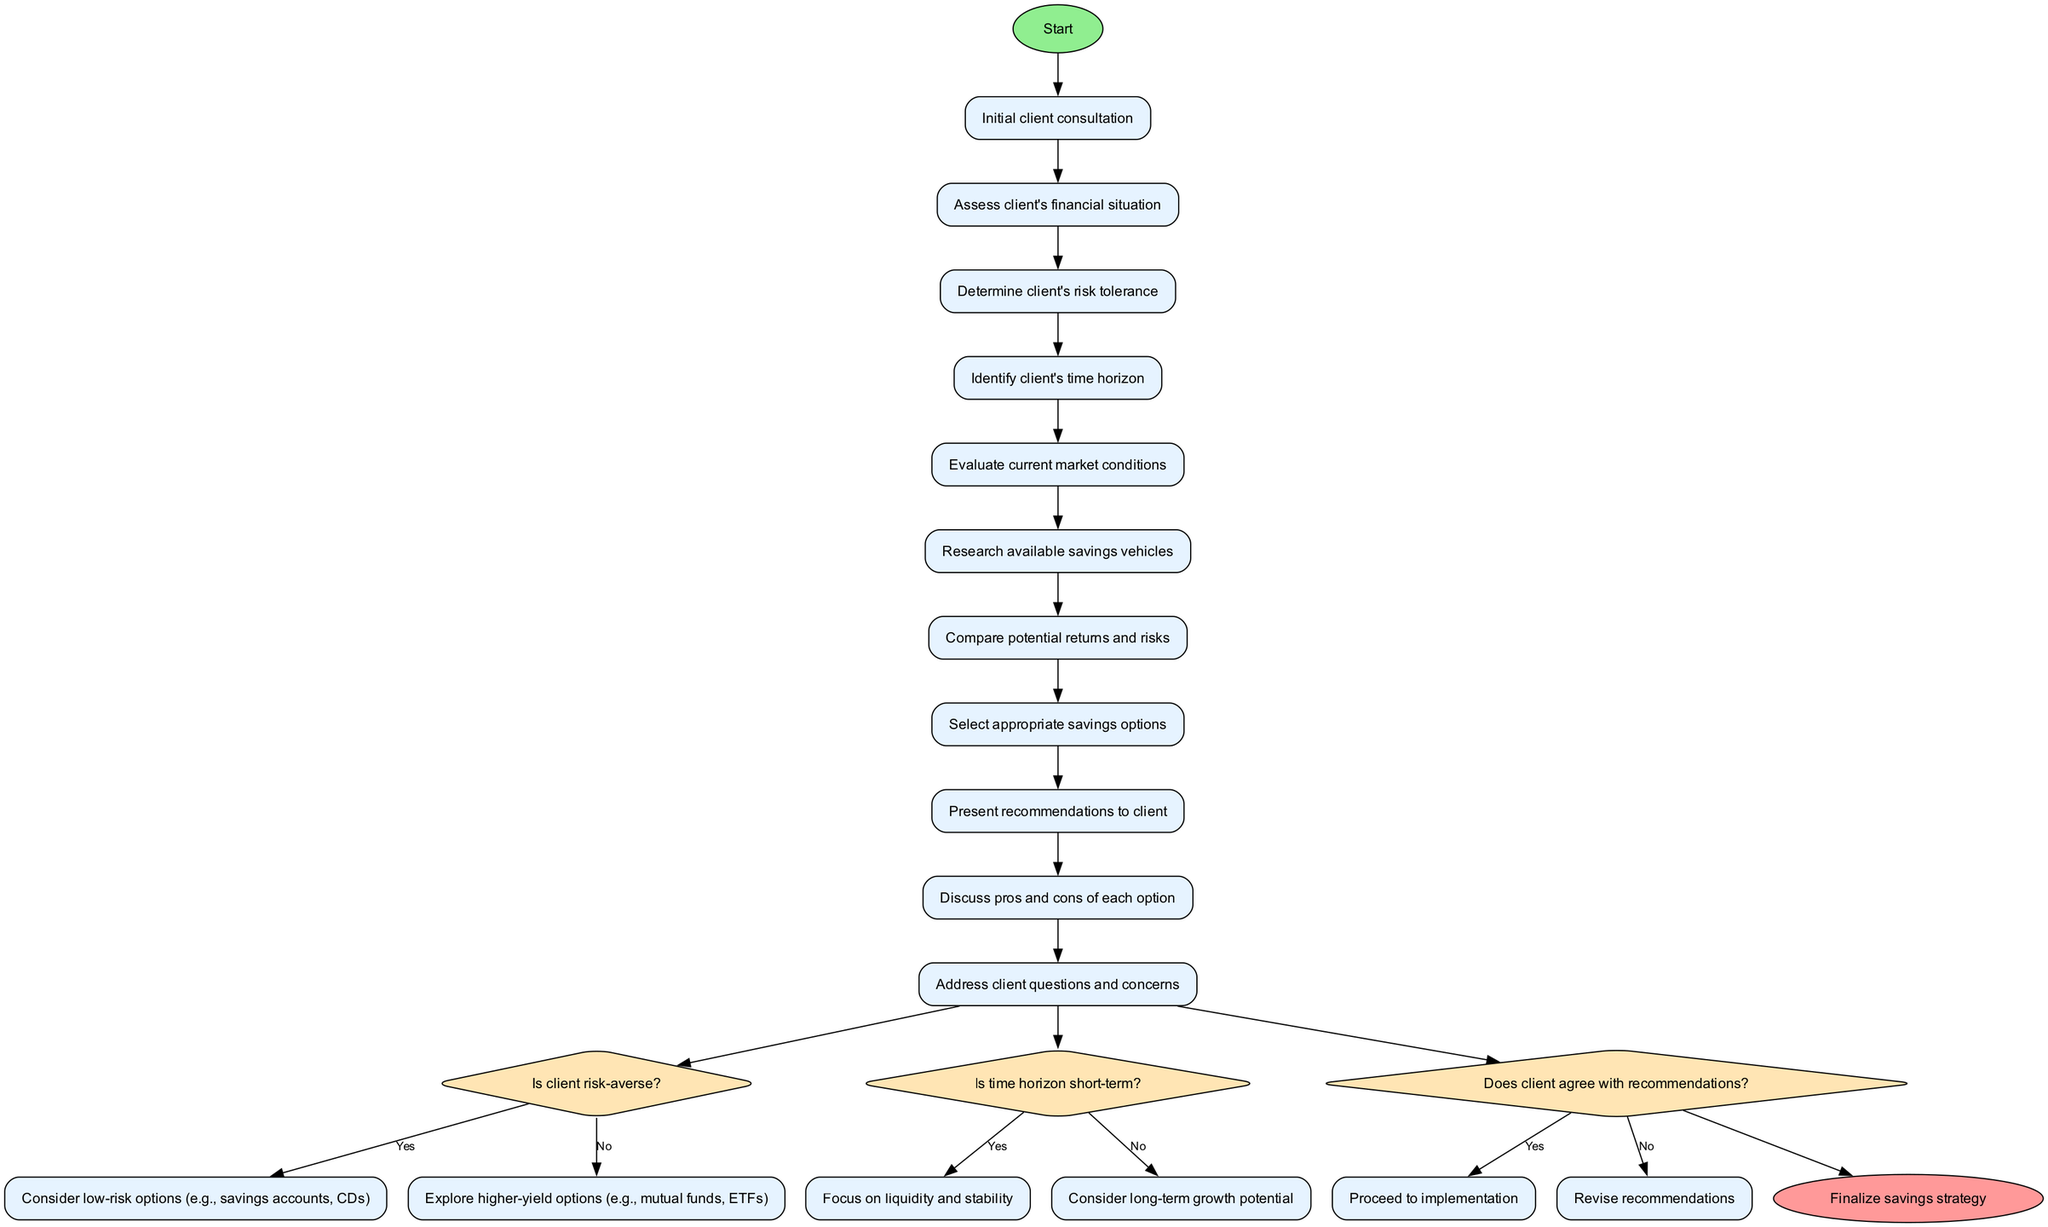What is the first activity in the diagram? The diagram begins with the "Initial client consultation" as the starting point. From the start node, the first activity is clearly labeled as the next step.
Answer: Initial client consultation How many activities are there in total? Counting the activities listed in the diagram, there are nine defined activities that follow the initial client consultation.
Answer: 9 What question is asked after determining the client's risk tolerance? After assessing the client's financial situation and determining their risk tolerance, the next decision made is regarding the client's time horizon, which is the question asked next.
Answer: Is time horizon short-term? What happens if the client is risk-averse? If the client is determined to be risk-averse, the path leads to considering low-risk options such as savings accounts or certificates of deposit, which is explicitly noted in the diagram.
Answer: Consider low-risk options (e.g., savings accounts, CDs) How does the process end? The process concludes at the end node labeled "Finalize savings strategy," which is reached after the decisions and recommendations have been addressed.
Answer: Finalize savings strategy What activities are conducted before presenting recommendations to the client? Before presenting recommendations, the diagram details the activities of comparing potential returns and risks and discussing the pros and cons of each option that the advisor must undertake.
Answer: Compare potential returns and risks, Discuss pros and cons of each option How is client feedback incorporated into the process? The client's feedback is evaluated at the decision point titled "Does client agree with recommendations?" If the client does not agree, the process loops back, indicating the need to revise the recommendations.
Answer: Revise recommendations What action is taken if the time horizon is not short-term? When the time horizon is not classified as short-term, the diagram directs the advisor to consider long-term growth potential, guiding the selection of appropriate investment strategies.
Answer: Consider long-term growth potential 